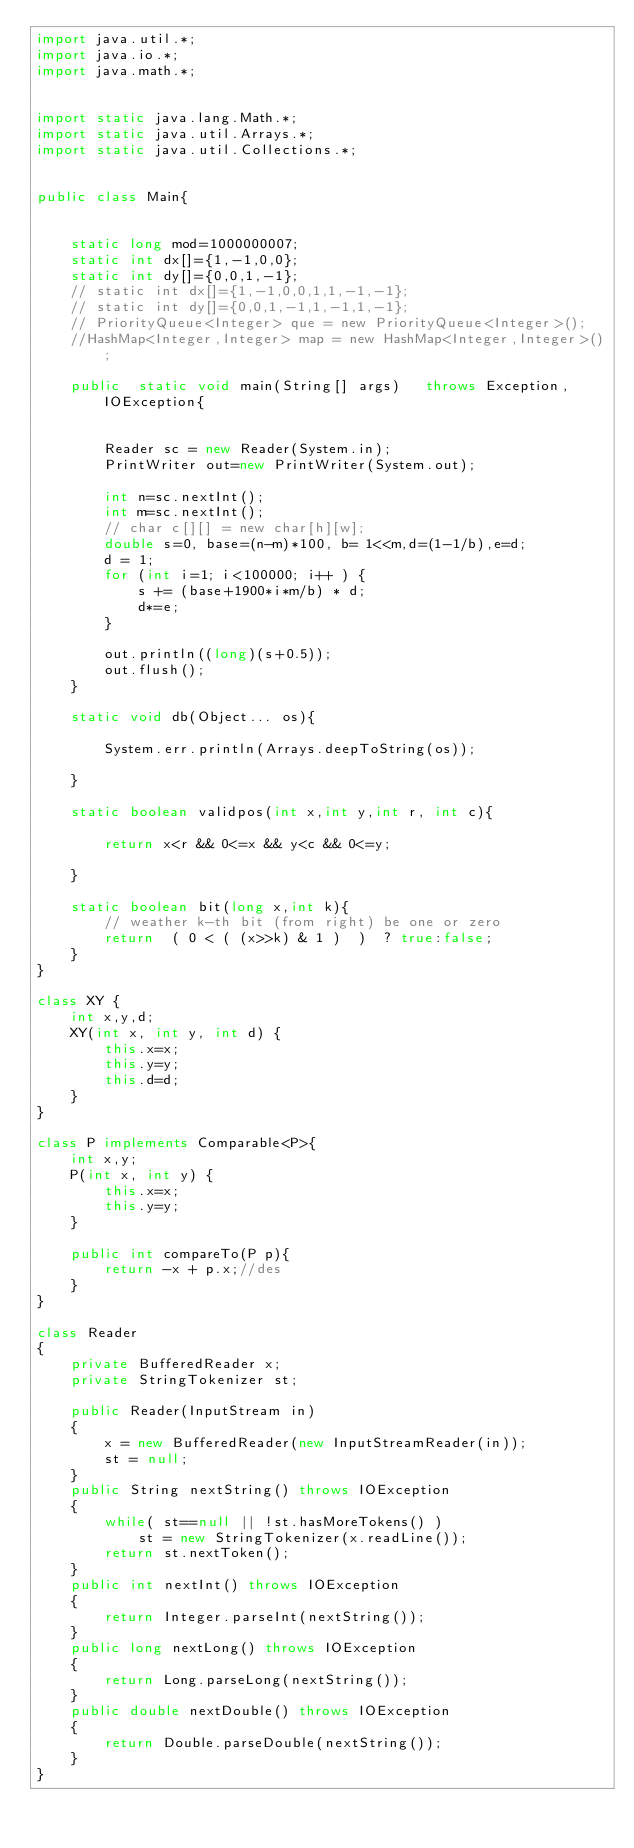Convert code to text. <code><loc_0><loc_0><loc_500><loc_500><_Java_>import java.util.*;
import java.io.*;
import java.math.*;
 
 
import static java.lang.Math.*;
import static java.util.Arrays.*;
import static java.util.Collections.*;
 
 
public class Main{ 
 
 
    static long mod=1000000007;
    static int dx[]={1,-1,0,0};
    static int dy[]={0,0,1,-1};
    // static int dx[]={1,-1,0,0,1,1,-1,-1};
    // static int dy[]={0,0,1,-1,1,-1,1,-1};
    // PriorityQueue<Integer> que = new PriorityQueue<Integer>(); 
    //HashMap<Integer,Integer> map = new HashMap<Integer,Integer>();
 
    public  static void main(String[] args)   throws Exception, IOException{
     
        
        Reader sc = new Reader(System.in);
        PrintWriter out=new PrintWriter(System.out);
     
        int n=sc.nextInt();
        int m=sc.nextInt();
        // char c[][] = new char[h][w];
        double s=0, base=(n-m)*100, b= 1<<m,d=(1-1/b),e=d;
        d = 1;
        for (int i=1; i<100000; i++ ) {
            s += (base+1900*i*m/b) * d;
            d*=e;
        }
       
        out.println((long)(s+0.5));
        out.flush();
    }
     
    static void db(Object... os){
     
        System.err.println(Arrays.deepToString(os));
     
    }
     
    static boolean validpos(int x,int y,int r, int c){
        
        return x<r && 0<=x && y<c && 0<=y;
        
    }
     
    static boolean bit(long x,int k){
        // weather k-th bit (from right) be one or zero
        return  ( 0 < ( (x>>k) & 1 )  )  ? true:false;
    }    
}
 
class XY {
    int x,y,d;
    XY(int x, int y, int d) {
        this.x=x;
        this.y=y;
        this.d=d;
    } 
}
 
class P implements Comparable<P>{
    int x,y;
    P(int x, int y) {
        this.x=x;
        this.y=y;
    } 
      
    public int compareTo(P p){
        return -x + p.x;//des
    } 
}
 
class Reader
{ 
    private BufferedReader x;
    private StringTokenizer st;
    
    public Reader(InputStream in)
    {
        x = new BufferedReader(new InputStreamReader(in));
        st = null;
    }
    public String nextString() throws IOException
    {
        while( st==null || !st.hasMoreTokens() )
            st = new StringTokenizer(x.readLine());
        return st.nextToken();
    }
    public int nextInt() throws IOException
    {
        return Integer.parseInt(nextString());
    }
    public long nextLong() throws IOException
    {
        return Long.parseLong(nextString());
    }
    public double nextDouble() throws IOException
    {
        return Double.parseDouble(nextString());
    }
}</code> 